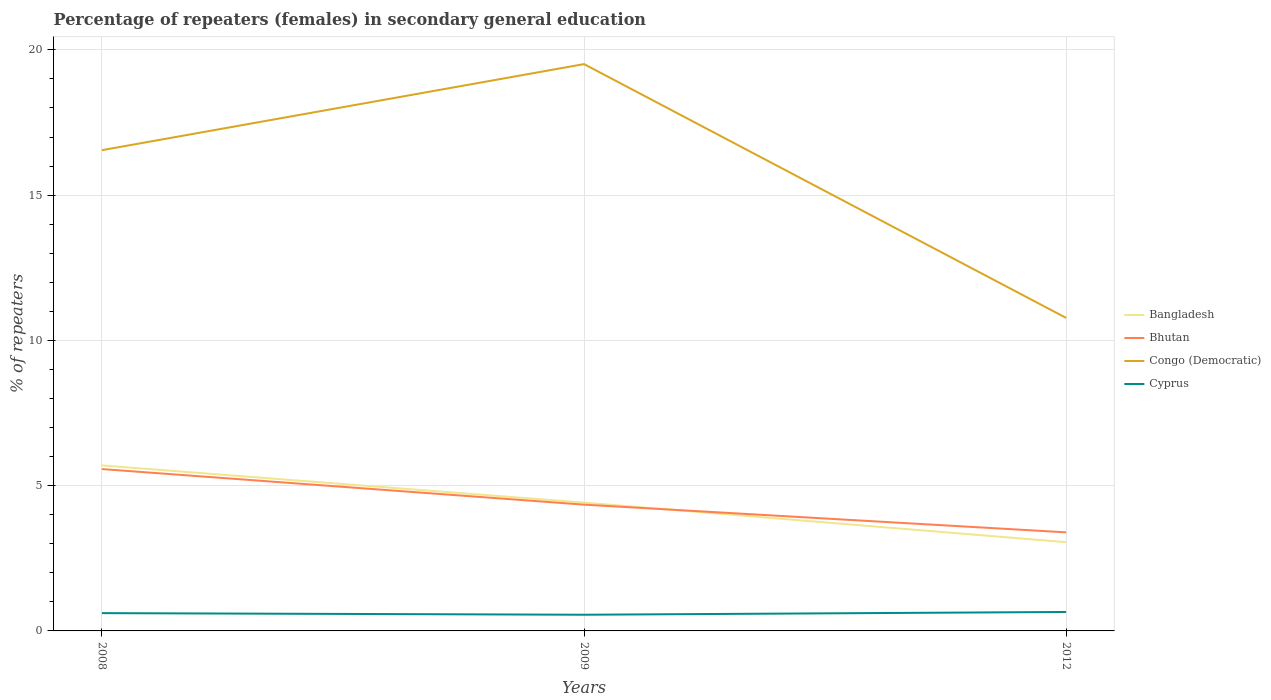Does the line corresponding to Cyprus intersect with the line corresponding to Bangladesh?
Provide a short and direct response. No. Is the number of lines equal to the number of legend labels?
Offer a very short reply. Yes. Across all years, what is the maximum percentage of female repeaters in Bangladesh?
Provide a short and direct response. 3.05. In which year was the percentage of female repeaters in Bhutan maximum?
Offer a very short reply. 2012. What is the total percentage of female repeaters in Congo (Democratic) in the graph?
Provide a short and direct response. -2.96. What is the difference between the highest and the second highest percentage of female repeaters in Cyprus?
Your answer should be compact. 0.1. What is the difference between the highest and the lowest percentage of female repeaters in Bhutan?
Your answer should be very brief. 1. How many lines are there?
Give a very brief answer. 4. What is the difference between two consecutive major ticks on the Y-axis?
Ensure brevity in your answer.  5. Does the graph contain grids?
Offer a very short reply. Yes. How are the legend labels stacked?
Offer a very short reply. Vertical. What is the title of the graph?
Offer a terse response. Percentage of repeaters (females) in secondary general education. What is the label or title of the Y-axis?
Ensure brevity in your answer.  % of repeaters. What is the % of repeaters of Bangladesh in 2008?
Keep it short and to the point. 5.7. What is the % of repeaters in Bhutan in 2008?
Give a very brief answer. 5.57. What is the % of repeaters in Congo (Democratic) in 2008?
Provide a short and direct response. 16.55. What is the % of repeaters of Cyprus in 2008?
Ensure brevity in your answer.  0.61. What is the % of repeaters in Bangladesh in 2009?
Keep it short and to the point. 4.42. What is the % of repeaters of Bhutan in 2009?
Give a very brief answer. 4.35. What is the % of repeaters in Congo (Democratic) in 2009?
Provide a short and direct response. 19.51. What is the % of repeaters of Cyprus in 2009?
Offer a terse response. 0.56. What is the % of repeaters of Bangladesh in 2012?
Make the answer very short. 3.05. What is the % of repeaters in Bhutan in 2012?
Make the answer very short. 3.39. What is the % of repeaters in Congo (Democratic) in 2012?
Offer a very short reply. 10.77. What is the % of repeaters in Cyprus in 2012?
Offer a very short reply. 0.65. Across all years, what is the maximum % of repeaters in Bangladesh?
Make the answer very short. 5.7. Across all years, what is the maximum % of repeaters of Bhutan?
Keep it short and to the point. 5.57. Across all years, what is the maximum % of repeaters of Congo (Democratic)?
Offer a terse response. 19.51. Across all years, what is the maximum % of repeaters of Cyprus?
Make the answer very short. 0.65. Across all years, what is the minimum % of repeaters in Bangladesh?
Make the answer very short. 3.05. Across all years, what is the minimum % of repeaters of Bhutan?
Ensure brevity in your answer.  3.39. Across all years, what is the minimum % of repeaters in Congo (Democratic)?
Keep it short and to the point. 10.77. Across all years, what is the minimum % of repeaters in Cyprus?
Keep it short and to the point. 0.56. What is the total % of repeaters of Bangladesh in the graph?
Give a very brief answer. 13.17. What is the total % of repeaters of Bhutan in the graph?
Keep it short and to the point. 13.31. What is the total % of repeaters of Congo (Democratic) in the graph?
Your answer should be very brief. 46.83. What is the total % of repeaters of Cyprus in the graph?
Offer a terse response. 1.82. What is the difference between the % of repeaters of Bangladesh in 2008 and that in 2009?
Provide a short and direct response. 1.28. What is the difference between the % of repeaters of Bhutan in 2008 and that in 2009?
Make the answer very short. 1.22. What is the difference between the % of repeaters in Congo (Democratic) in 2008 and that in 2009?
Keep it short and to the point. -2.96. What is the difference between the % of repeaters of Cyprus in 2008 and that in 2009?
Your answer should be compact. 0.06. What is the difference between the % of repeaters of Bangladesh in 2008 and that in 2012?
Ensure brevity in your answer.  2.64. What is the difference between the % of repeaters in Bhutan in 2008 and that in 2012?
Keep it short and to the point. 2.18. What is the difference between the % of repeaters of Congo (Democratic) in 2008 and that in 2012?
Make the answer very short. 5.77. What is the difference between the % of repeaters in Cyprus in 2008 and that in 2012?
Offer a terse response. -0.04. What is the difference between the % of repeaters in Bangladesh in 2009 and that in 2012?
Offer a terse response. 1.36. What is the difference between the % of repeaters of Bhutan in 2009 and that in 2012?
Provide a succinct answer. 0.95. What is the difference between the % of repeaters in Congo (Democratic) in 2009 and that in 2012?
Your response must be concise. 8.74. What is the difference between the % of repeaters in Cyprus in 2009 and that in 2012?
Offer a terse response. -0.1. What is the difference between the % of repeaters in Bangladesh in 2008 and the % of repeaters in Bhutan in 2009?
Your answer should be very brief. 1.35. What is the difference between the % of repeaters in Bangladesh in 2008 and the % of repeaters in Congo (Democratic) in 2009?
Give a very brief answer. -13.81. What is the difference between the % of repeaters of Bangladesh in 2008 and the % of repeaters of Cyprus in 2009?
Offer a very short reply. 5.14. What is the difference between the % of repeaters in Bhutan in 2008 and the % of repeaters in Congo (Democratic) in 2009?
Ensure brevity in your answer.  -13.94. What is the difference between the % of repeaters in Bhutan in 2008 and the % of repeaters in Cyprus in 2009?
Your answer should be very brief. 5.01. What is the difference between the % of repeaters of Congo (Democratic) in 2008 and the % of repeaters of Cyprus in 2009?
Offer a terse response. 15.99. What is the difference between the % of repeaters in Bangladesh in 2008 and the % of repeaters in Bhutan in 2012?
Give a very brief answer. 2.3. What is the difference between the % of repeaters in Bangladesh in 2008 and the % of repeaters in Congo (Democratic) in 2012?
Ensure brevity in your answer.  -5.08. What is the difference between the % of repeaters of Bangladesh in 2008 and the % of repeaters of Cyprus in 2012?
Your answer should be very brief. 5.04. What is the difference between the % of repeaters in Bhutan in 2008 and the % of repeaters in Congo (Democratic) in 2012?
Your response must be concise. -5.2. What is the difference between the % of repeaters of Bhutan in 2008 and the % of repeaters of Cyprus in 2012?
Your response must be concise. 4.92. What is the difference between the % of repeaters of Congo (Democratic) in 2008 and the % of repeaters of Cyprus in 2012?
Your answer should be very brief. 15.9. What is the difference between the % of repeaters of Bangladesh in 2009 and the % of repeaters of Bhutan in 2012?
Make the answer very short. 1.02. What is the difference between the % of repeaters of Bangladesh in 2009 and the % of repeaters of Congo (Democratic) in 2012?
Give a very brief answer. -6.36. What is the difference between the % of repeaters of Bangladesh in 2009 and the % of repeaters of Cyprus in 2012?
Your answer should be compact. 3.76. What is the difference between the % of repeaters of Bhutan in 2009 and the % of repeaters of Congo (Democratic) in 2012?
Provide a short and direct response. -6.43. What is the difference between the % of repeaters in Bhutan in 2009 and the % of repeaters in Cyprus in 2012?
Provide a short and direct response. 3.69. What is the difference between the % of repeaters of Congo (Democratic) in 2009 and the % of repeaters of Cyprus in 2012?
Your answer should be very brief. 18.86. What is the average % of repeaters in Bangladesh per year?
Provide a short and direct response. 4.39. What is the average % of repeaters of Bhutan per year?
Make the answer very short. 4.44. What is the average % of repeaters in Congo (Democratic) per year?
Provide a succinct answer. 15.61. What is the average % of repeaters of Cyprus per year?
Keep it short and to the point. 0.61. In the year 2008, what is the difference between the % of repeaters of Bangladesh and % of repeaters of Bhutan?
Keep it short and to the point. 0.13. In the year 2008, what is the difference between the % of repeaters in Bangladesh and % of repeaters in Congo (Democratic)?
Provide a short and direct response. -10.85. In the year 2008, what is the difference between the % of repeaters of Bangladesh and % of repeaters of Cyprus?
Make the answer very short. 5.08. In the year 2008, what is the difference between the % of repeaters in Bhutan and % of repeaters in Congo (Democratic)?
Your answer should be compact. -10.98. In the year 2008, what is the difference between the % of repeaters in Bhutan and % of repeaters in Cyprus?
Your response must be concise. 4.96. In the year 2008, what is the difference between the % of repeaters in Congo (Democratic) and % of repeaters in Cyprus?
Your response must be concise. 15.94. In the year 2009, what is the difference between the % of repeaters in Bangladesh and % of repeaters in Bhutan?
Ensure brevity in your answer.  0.07. In the year 2009, what is the difference between the % of repeaters in Bangladesh and % of repeaters in Congo (Democratic)?
Provide a short and direct response. -15.09. In the year 2009, what is the difference between the % of repeaters of Bangladesh and % of repeaters of Cyprus?
Offer a very short reply. 3.86. In the year 2009, what is the difference between the % of repeaters in Bhutan and % of repeaters in Congo (Democratic)?
Make the answer very short. -15.16. In the year 2009, what is the difference between the % of repeaters of Bhutan and % of repeaters of Cyprus?
Give a very brief answer. 3.79. In the year 2009, what is the difference between the % of repeaters of Congo (Democratic) and % of repeaters of Cyprus?
Keep it short and to the point. 18.95. In the year 2012, what is the difference between the % of repeaters in Bangladesh and % of repeaters in Bhutan?
Provide a succinct answer. -0.34. In the year 2012, what is the difference between the % of repeaters in Bangladesh and % of repeaters in Congo (Democratic)?
Your answer should be compact. -7.72. In the year 2012, what is the difference between the % of repeaters in Bangladesh and % of repeaters in Cyprus?
Provide a short and direct response. 2.4. In the year 2012, what is the difference between the % of repeaters in Bhutan and % of repeaters in Congo (Democratic)?
Offer a terse response. -7.38. In the year 2012, what is the difference between the % of repeaters of Bhutan and % of repeaters of Cyprus?
Ensure brevity in your answer.  2.74. In the year 2012, what is the difference between the % of repeaters of Congo (Democratic) and % of repeaters of Cyprus?
Your answer should be compact. 10.12. What is the ratio of the % of repeaters in Bangladesh in 2008 to that in 2009?
Offer a terse response. 1.29. What is the ratio of the % of repeaters in Bhutan in 2008 to that in 2009?
Give a very brief answer. 1.28. What is the ratio of the % of repeaters in Congo (Democratic) in 2008 to that in 2009?
Ensure brevity in your answer.  0.85. What is the ratio of the % of repeaters of Cyprus in 2008 to that in 2009?
Make the answer very short. 1.1. What is the ratio of the % of repeaters in Bangladesh in 2008 to that in 2012?
Keep it short and to the point. 1.87. What is the ratio of the % of repeaters of Bhutan in 2008 to that in 2012?
Ensure brevity in your answer.  1.64. What is the ratio of the % of repeaters in Congo (Democratic) in 2008 to that in 2012?
Your answer should be very brief. 1.54. What is the ratio of the % of repeaters in Cyprus in 2008 to that in 2012?
Offer a terse response. 0.94. What is the ratio of the % of repeaters in Bangladesh in 2009 to that in 2012?
Your answer should be compact. 1.45. What is the ratio of the % of repeaters in Bhutan in 2009 to that in 2012?
Your answer should be very brief. 1.28. What is the ratio of the % of repeaters in Congo (Democratic) in 2009 to that in 2012?
Your answer should be compact. 1.81. What is the ratio of the % of repeaters of Cyprus in 2009 to that in 2012?
Provide a succinct answer. 0.85. What is the difference between the highest and the second highest % of repeaters of Bangladesh?
Make the answer very short. 1.28. What is the difference between the highest and the second highest % of repeaters in Bhutan?
Your answer should be compact. 1.22. What is the difference between the highest and the second highest % of repeaters in Congo (Democratic)?
Offer a very short reply. 2.96. What is the difference between the highest and the second highest % of repeaters of Cyprus?
Keep it short and to the point. 0.04. What is the difference between the highest and the lowest % of repeaters in Bangladesh?
Offer a very short reply. 2.64. What is the difference between the highest and the lowest % of repeaters of Bhutan?
Give a very brief answer. 2.18. What is the difference between the highest and the lowest % of repeaters of Congo (Democratic)?
Offer a very short reply. 8.74. What is the difference between the highest and the lowest % of repeaters of Cyprus?
Provide a succinct answer. 0.1. 